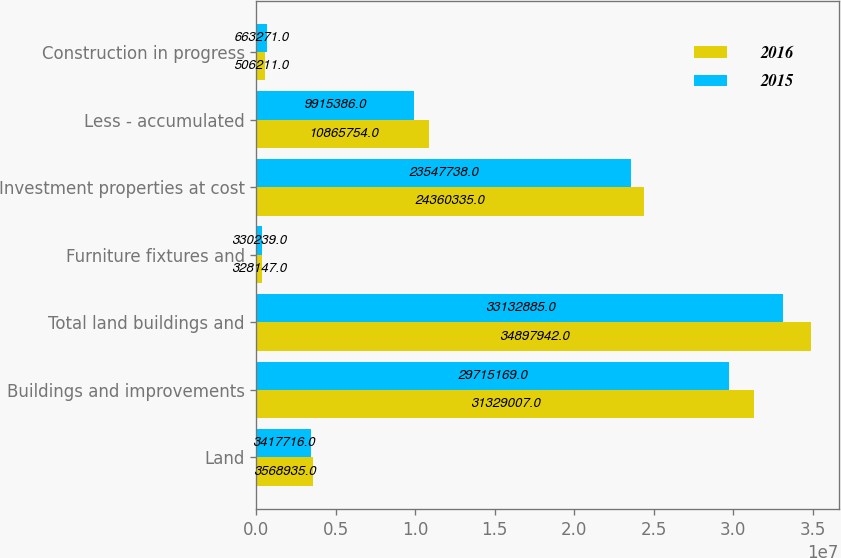Convert chart to OTSL. <chart><loc_0><loc_0><loc_500><loc_500><stacked_bar_chart><ecel><fcel>Land<fcel>Buildings and improvements<fcel>Total land buildings and<fcel>Furniture fixtures and<fcel>Investment properties at cost<fcel>Less - accumulated<fcel>Construction in progress<nl><fcel>2016<fcel>3.56894e+06<fcel>3.1329e+07<fcel>3.48979e+07<fcel>328147<fcel>2.43603e+07<fcel>1.08658e+07<fcel>506211<nl><fcel>2015<fcel>3.41772e+06<fcel>2.97152e+07<fcel>3.31329e+07<fcel>330239<fcel>2.35477e+07<fcel>9.91539e+06<fcel>663271<nl></chart> 